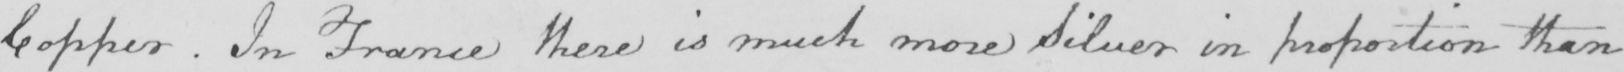Can you read and transcribe this handwriting? Copper . In France there is much more Silver in proportion than 